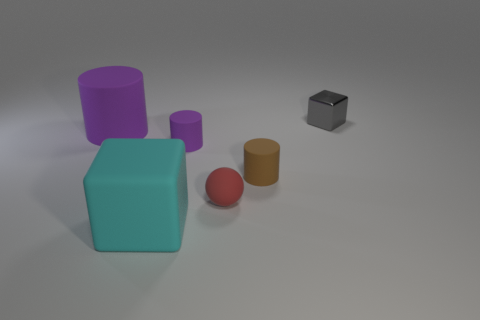Does the big thing behind the large matte cube have the same shape as the tiny red object behind the large cyan rubber block?
Give a very brief answer. No. Is there a small red object that has the same material as the big cube?
Provide a succinct answer. Yes. The metal object is what color?
Give a very brief answer. Gray. What is the size of the cube that is in front of the red rubber thing?
Keep it short and to the point. Large. How many other cylinders are the same color as the big rubber cylinder?
Your answer should be very brief. 1. There is a purple cylinder that is to the right of the cyan cube; are there any tiny blocks behind it?
Ensure brevity in your answer.  Yes. Do the big matte object behind the cyan thing and the tiny matte cylinder that is on the left side of the brown rubber cylinder have the same color?
Your answer should be very brief. Yes. What color is the cylinder that is the same size as the rubber block?
Your response must be concise. Purple. Are there an equal number of brown cylinders that are behind the small red object and large objects that are behind the big cyan matte cube?
Give a very brief answer. Yes. What material is the block that is right of the rubber object that is in front of the red matte object?
Your response must be concise. Metal. 